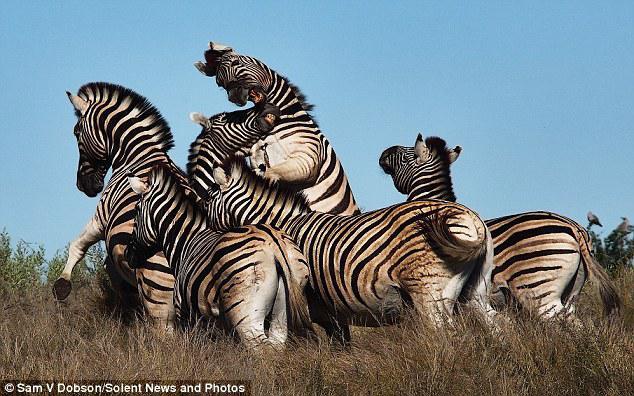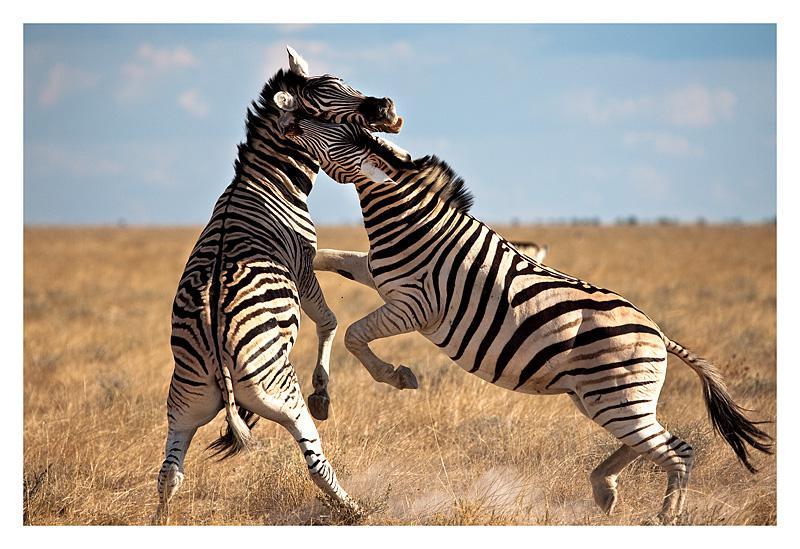The first image is the image on the left, the second image is the image on the right. For the images shown, is this caption "In at least one image there is a mother and calf zebra touching noses." true? Answer yes or no. No. The first image is the image on the left, the second image is the image on the right. Analyze the images presented: Is the assertion "One image shows two zebras face-to-face and standing upright with their heads crossed." valid? Answer yes or no. Yes. 